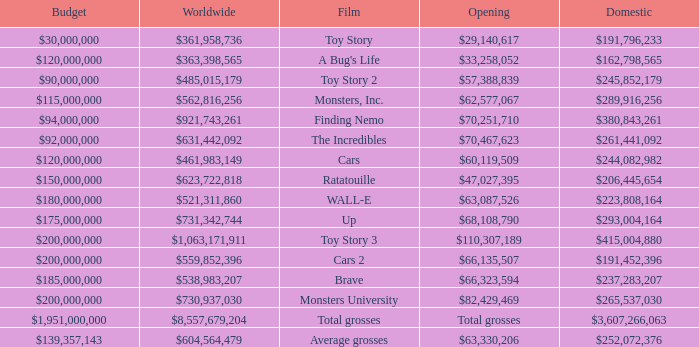WHAT IS THE WORLDWIDE BOX OFFICE FOR BRAVE? $538,983,207. 